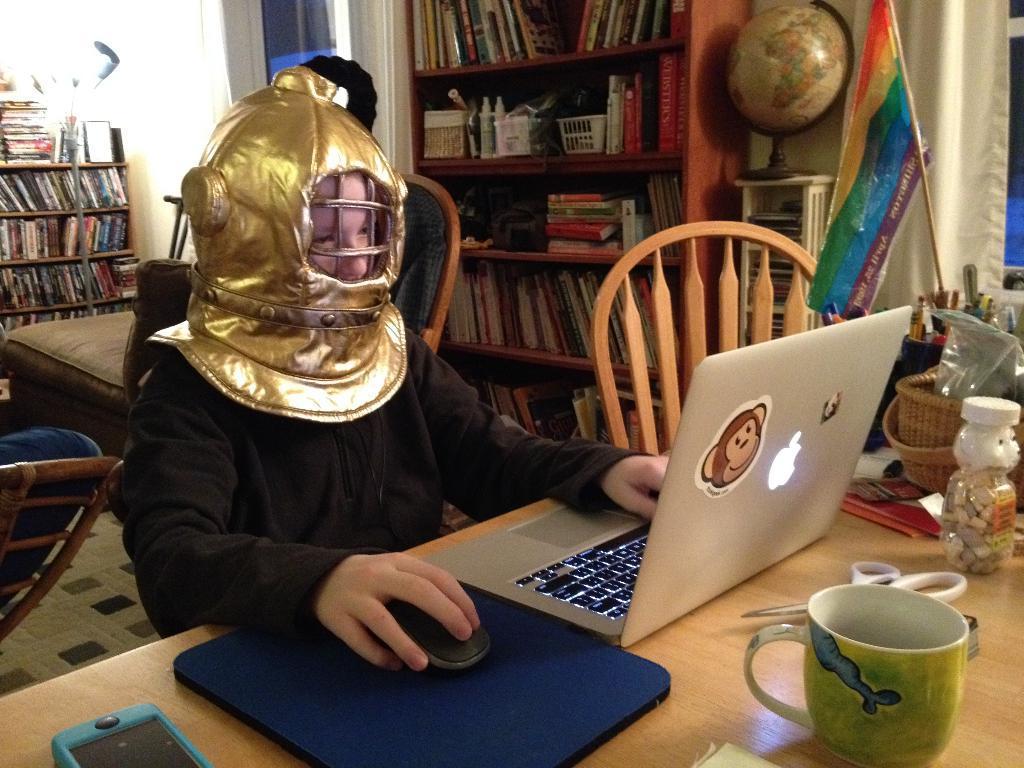Can you describe this image briefly? This picture shows a boy working on the laptop and he holds a mouse in his hand and we see cup, scissors and a mobile on the table and we see a book shelf on the right 